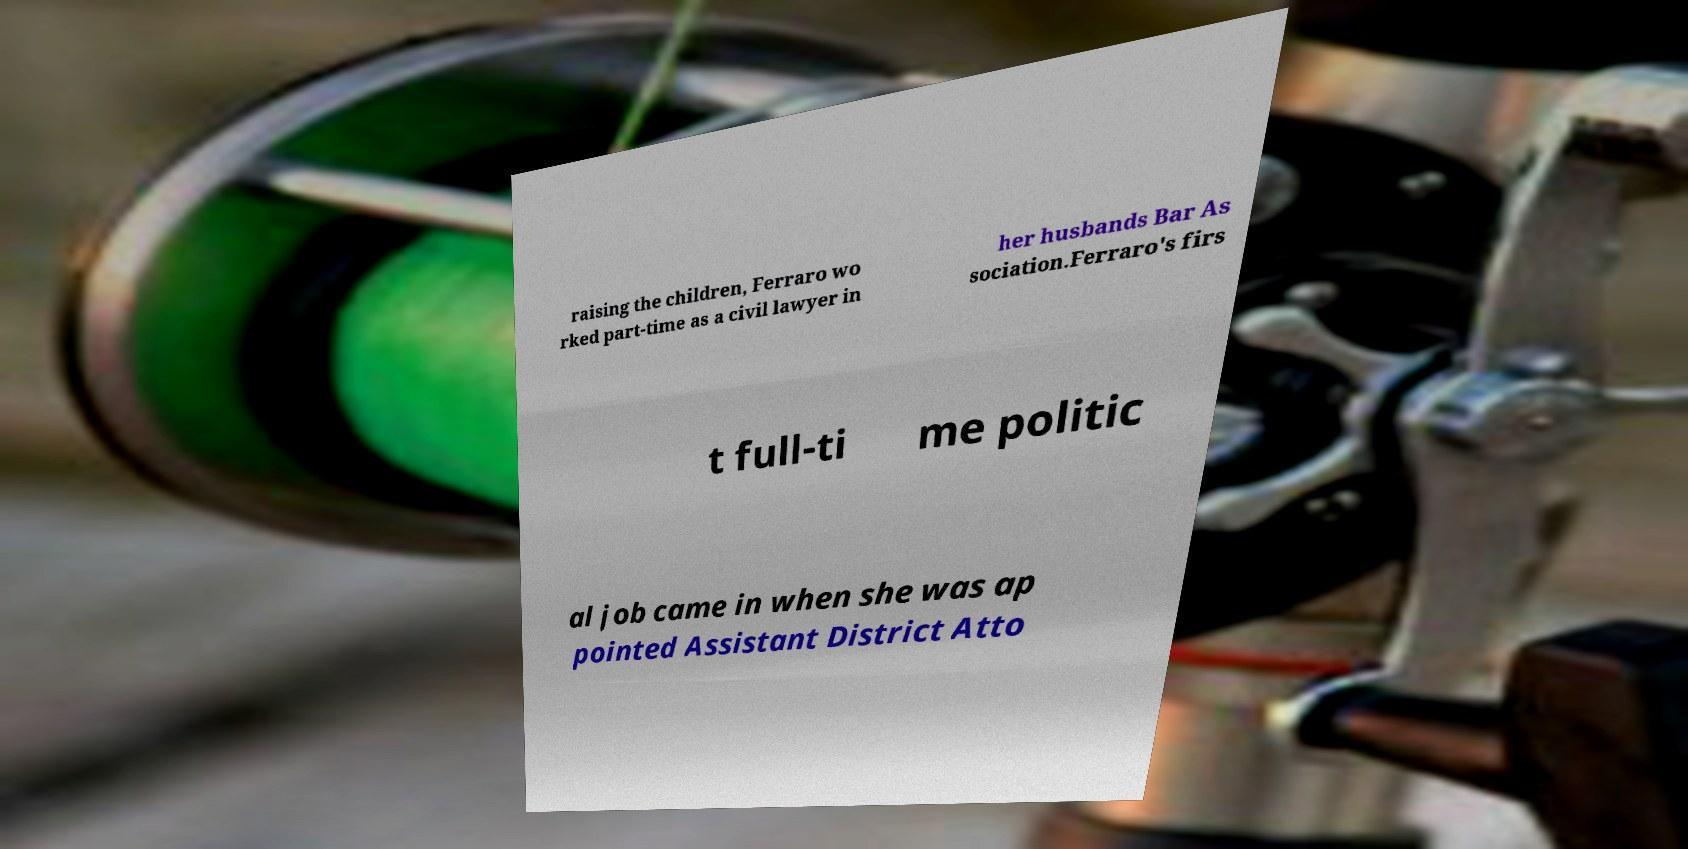Can you accurately transcribe the text from the provided image for me? raising the children, Ferraro wo rked part-time as a civil lawyer in her husbands Bar As sociation.Ferraro's firs t full-ti me politic al job came in when she was ap pointed Assistant District Atto 